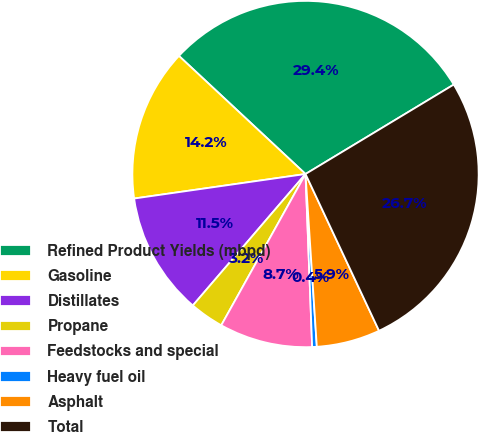Convert chart. <chart><loc_0><loc_0><loc_500><loc_500><pie_chart><fcel>Refined Product Yields (mbpd)<fcel>Gasoline<fcel>Distillates<fcel>Propane<fcel>Feedstocks and special<fcel>Heavy fuel oil<fcel>Asphalt<fcel>Total<nl><fcel>29.41%<fcel>14.21%<fcel>11.46%<fcel>3.19%<fcel>8.7%<fcel>0.43%<fcel>5.94%<fcel>26.66%<nl></chart> 